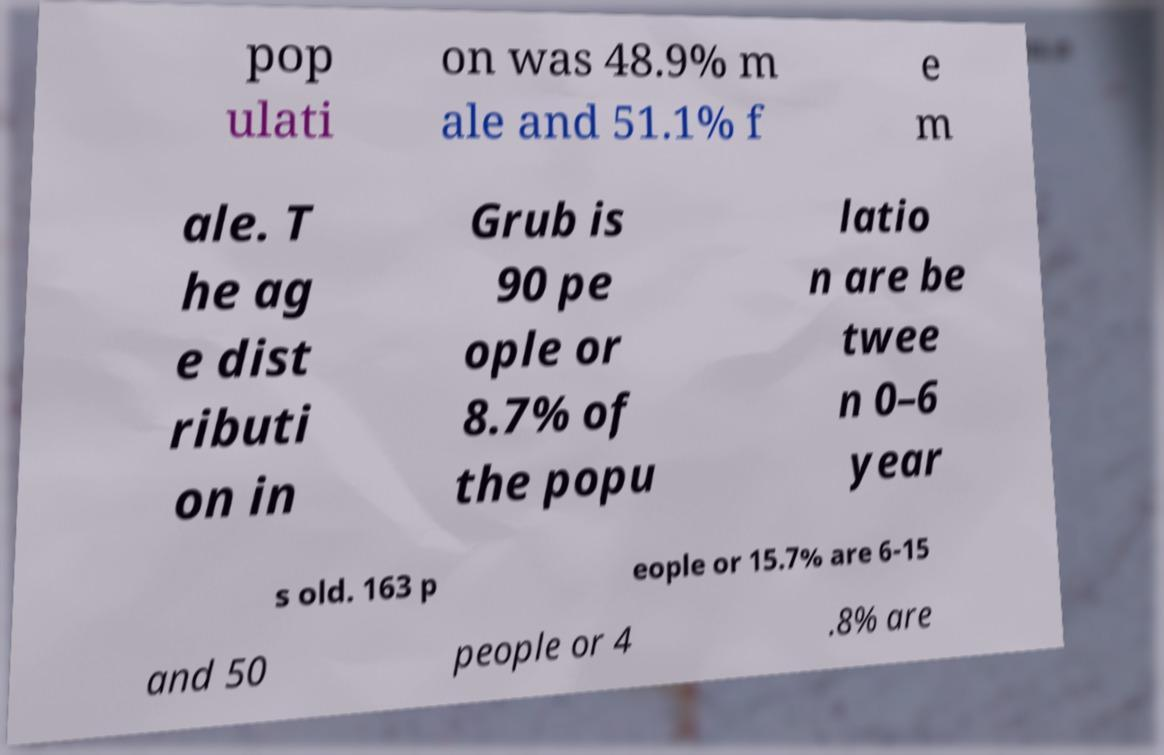What messages or text are displayed in this image? I need them in a readable, typed format. pop ulati on was 48.9% m ale and 51.1% f e m ale. T he ag e dist ributi on in Grub is 90 pe ople or 8.7% of the popu latio n are be twee n 0–6 year s old. 163 p eople or 15.7% are 6-15 and 50 people or 4 .8% are 